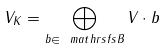Convert formula to latex. <formula><loc_0><loc_0><loc_500><loc_500>V _ { K } = \bigoplus _ { b \in \ m a t h r s f s { B } } V \cdot b</formula> 